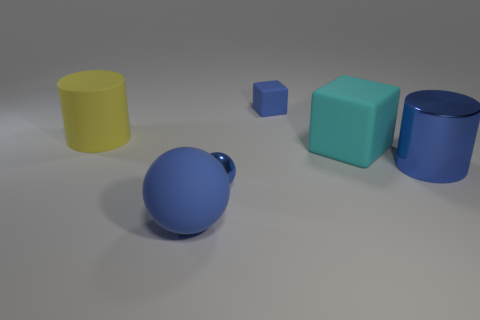Are there any small matte objects that have the same color as the matte sphere?
Provide a short and direct response. Yes. Is the small metallic sphere the same color as the small matte cube?
Keep it short and to the point. Yes. Is the number of big blue metal objects behind the matte cylinder the same as the number of blue matte things on the right side of the matte ball?
Offer a very short reply. No. Is the shape of the cyan object the same as the blue rubber object behind the blue rubber ball?
Give a very brief answer. Yes. There is a block that is the same color as the big sphere; what is it made of?
Provide a succinct answer. Rubber. Is the big sphere made of the same material as the tiny blue object that is behind the small blue metallic ball?
Provide a succinct answer. Yes. What color is the matte thing that is on the right side of the small blue object that is behind the blue shiny object in front of the metallic cylinder?
Offer a very short reply. Cyan. Is the color of the small shiny sphere the same as the cylinder on the right side of the small rubber cube?
Ensure brevity in your answer.  Yes. The shiny ball is what color?
Offer a very short reply. Blue. What shape is the rubber object that is left of the big blue object in front of the large shiny thing that is in front of the cyan matte object?
Offer a very short reply. Cylinder. 